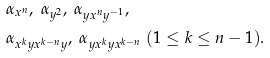Convert formula to latex. <formula><loc_0><loc_0><loc_500><loc_500>& \alpha _ { x ^ { n } } , \ \alpha _ { y ^ { 2 } } , \ \alpha _ { y x ^ { n } y ^ { - 1 } } , \\ & \alpha _ { x ^ { k } y x ^ { k - n } y } , \ \alpha _ { y x ^ { k } y x ^ { k - n } } \ ( 1 \leq k \leq n - 1 ) .</formula> 